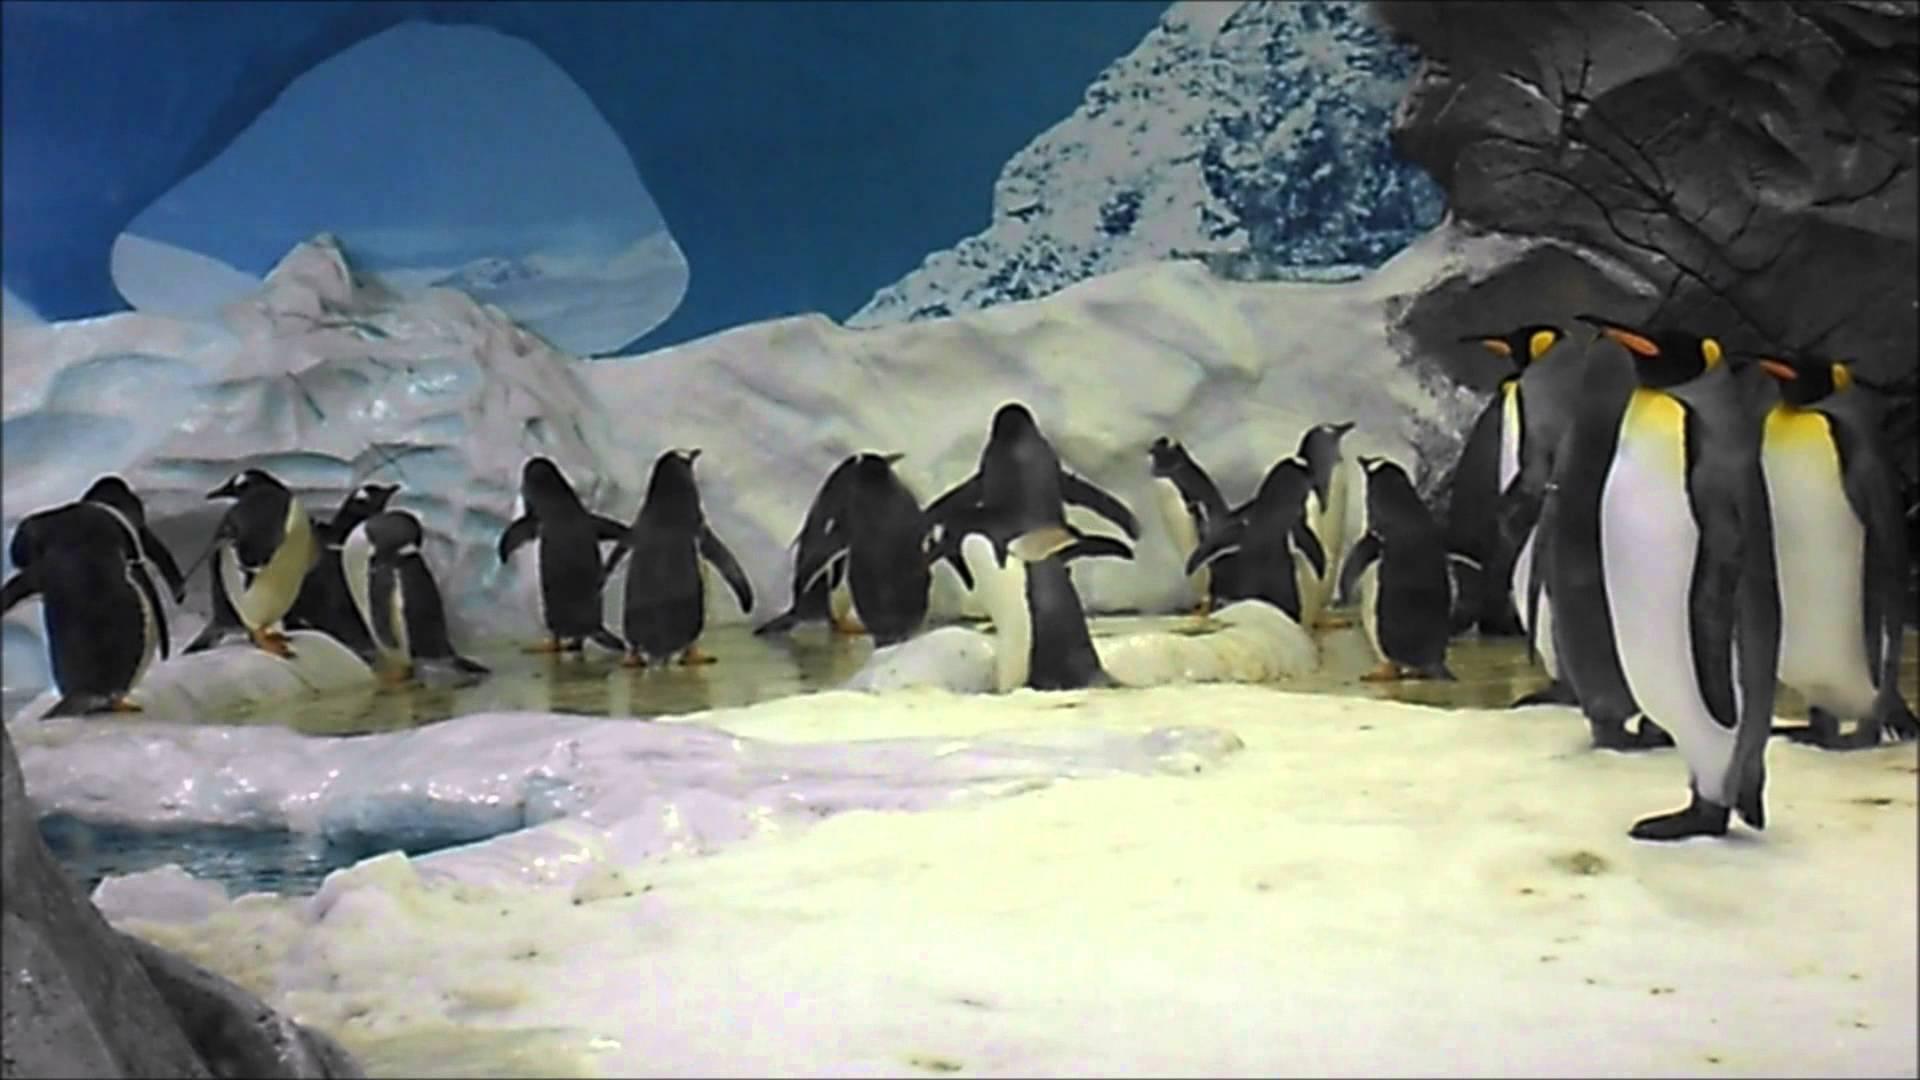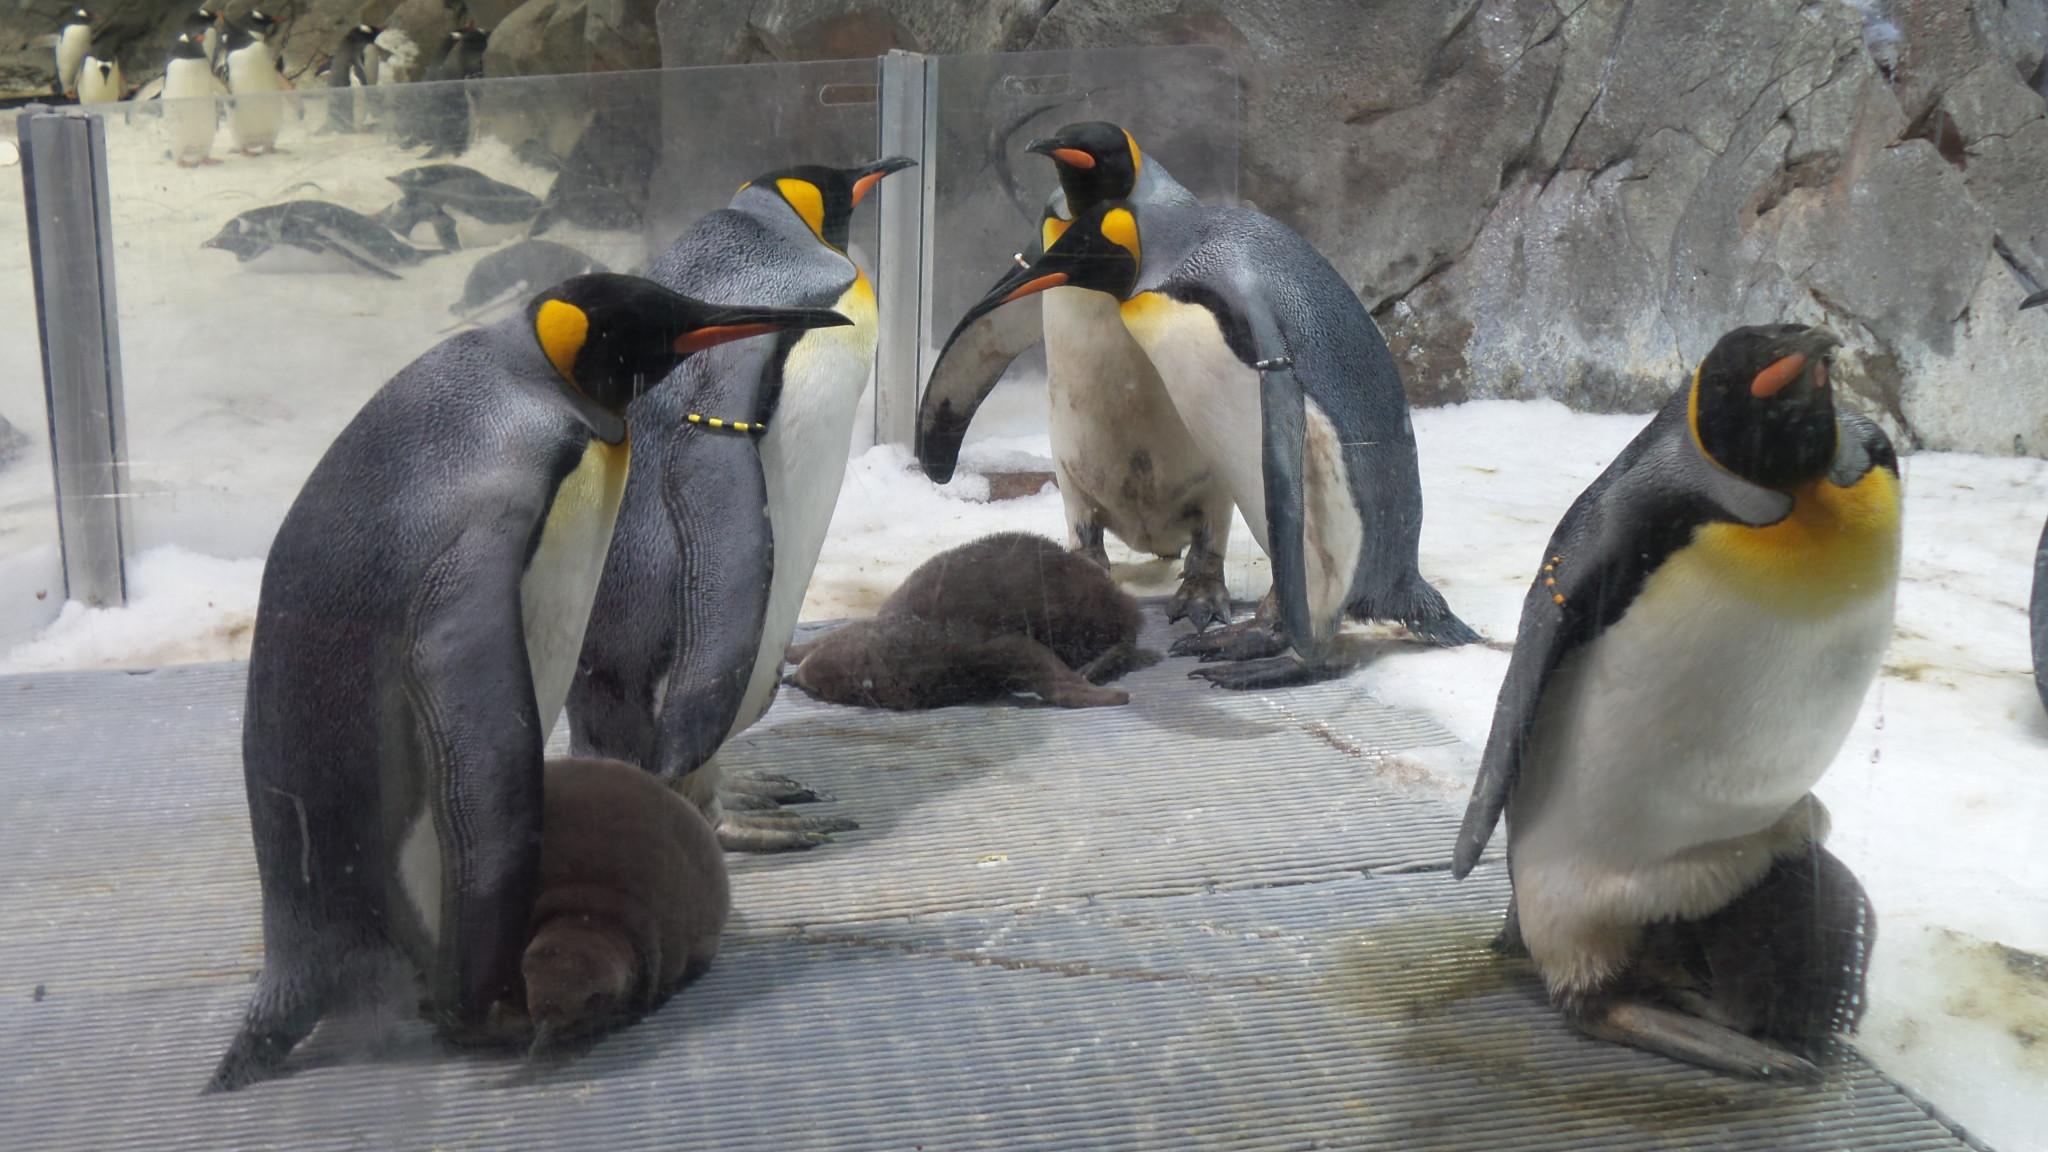The first image is the image on the left, the second image is the image on the right. For the images displayed, is the sentence "We can see exactly two baby penguins." factually correct? Answer yes or no. No. The first image is the image on the left, the second image is the image on the right. For the images shown, is this caption "Both photos in the pair have adult penguins and young penguins." true? Answer yes or no. No. 